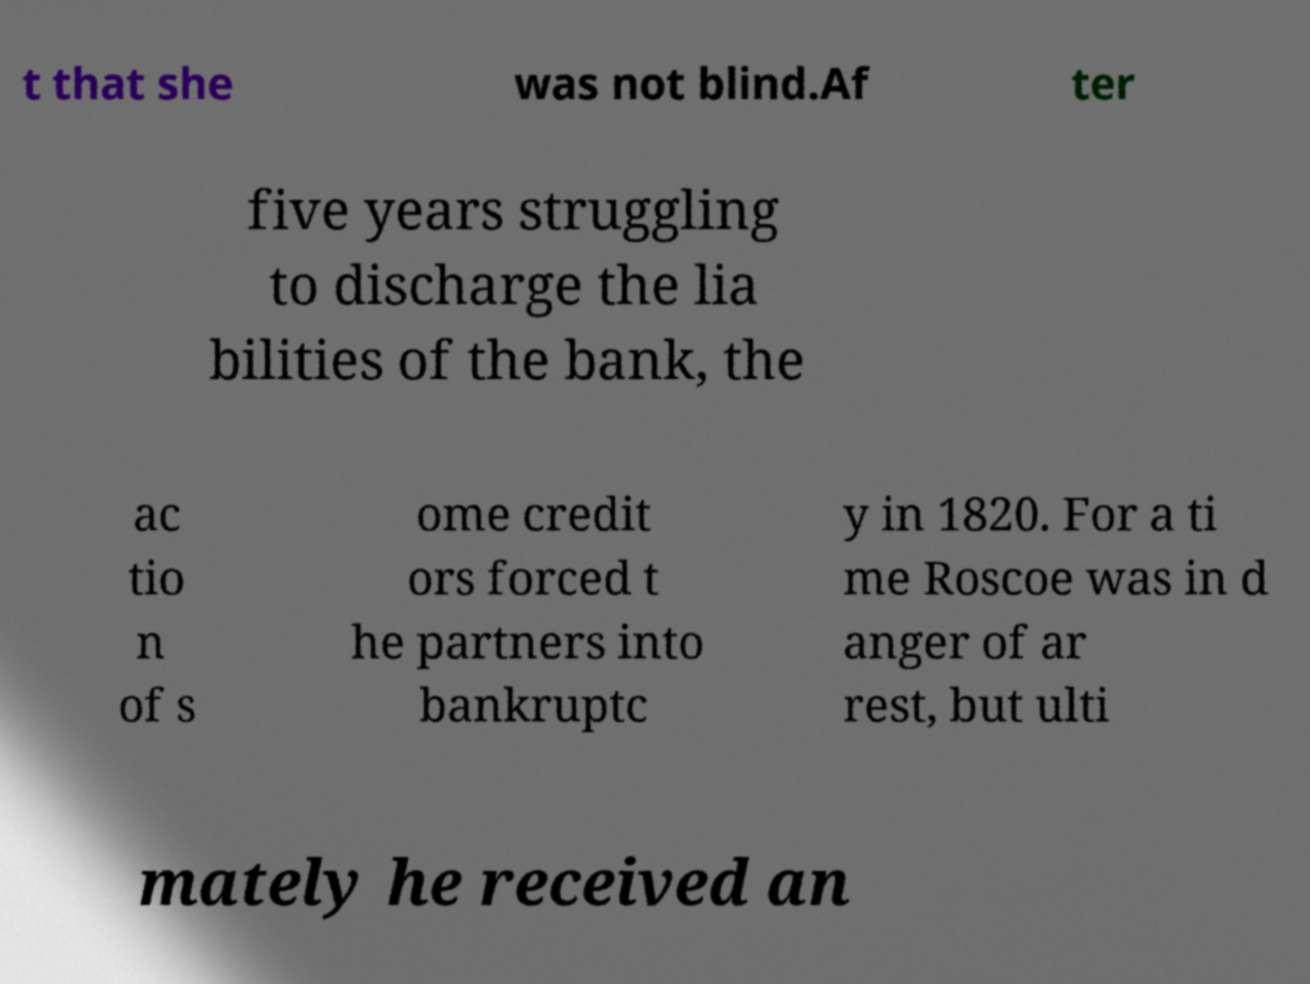For documentation purposes, I need the text within this image transcribed. Could you provide that? t that she was not blind.Af ter five years struggling to discharge the lia bilities of the bank, the ac tio n of s ome credit ors forced t he partners into bankruptc y in 1820. For a ti me Roscoe was in d anger of ar rest, but ulti mately he received an 